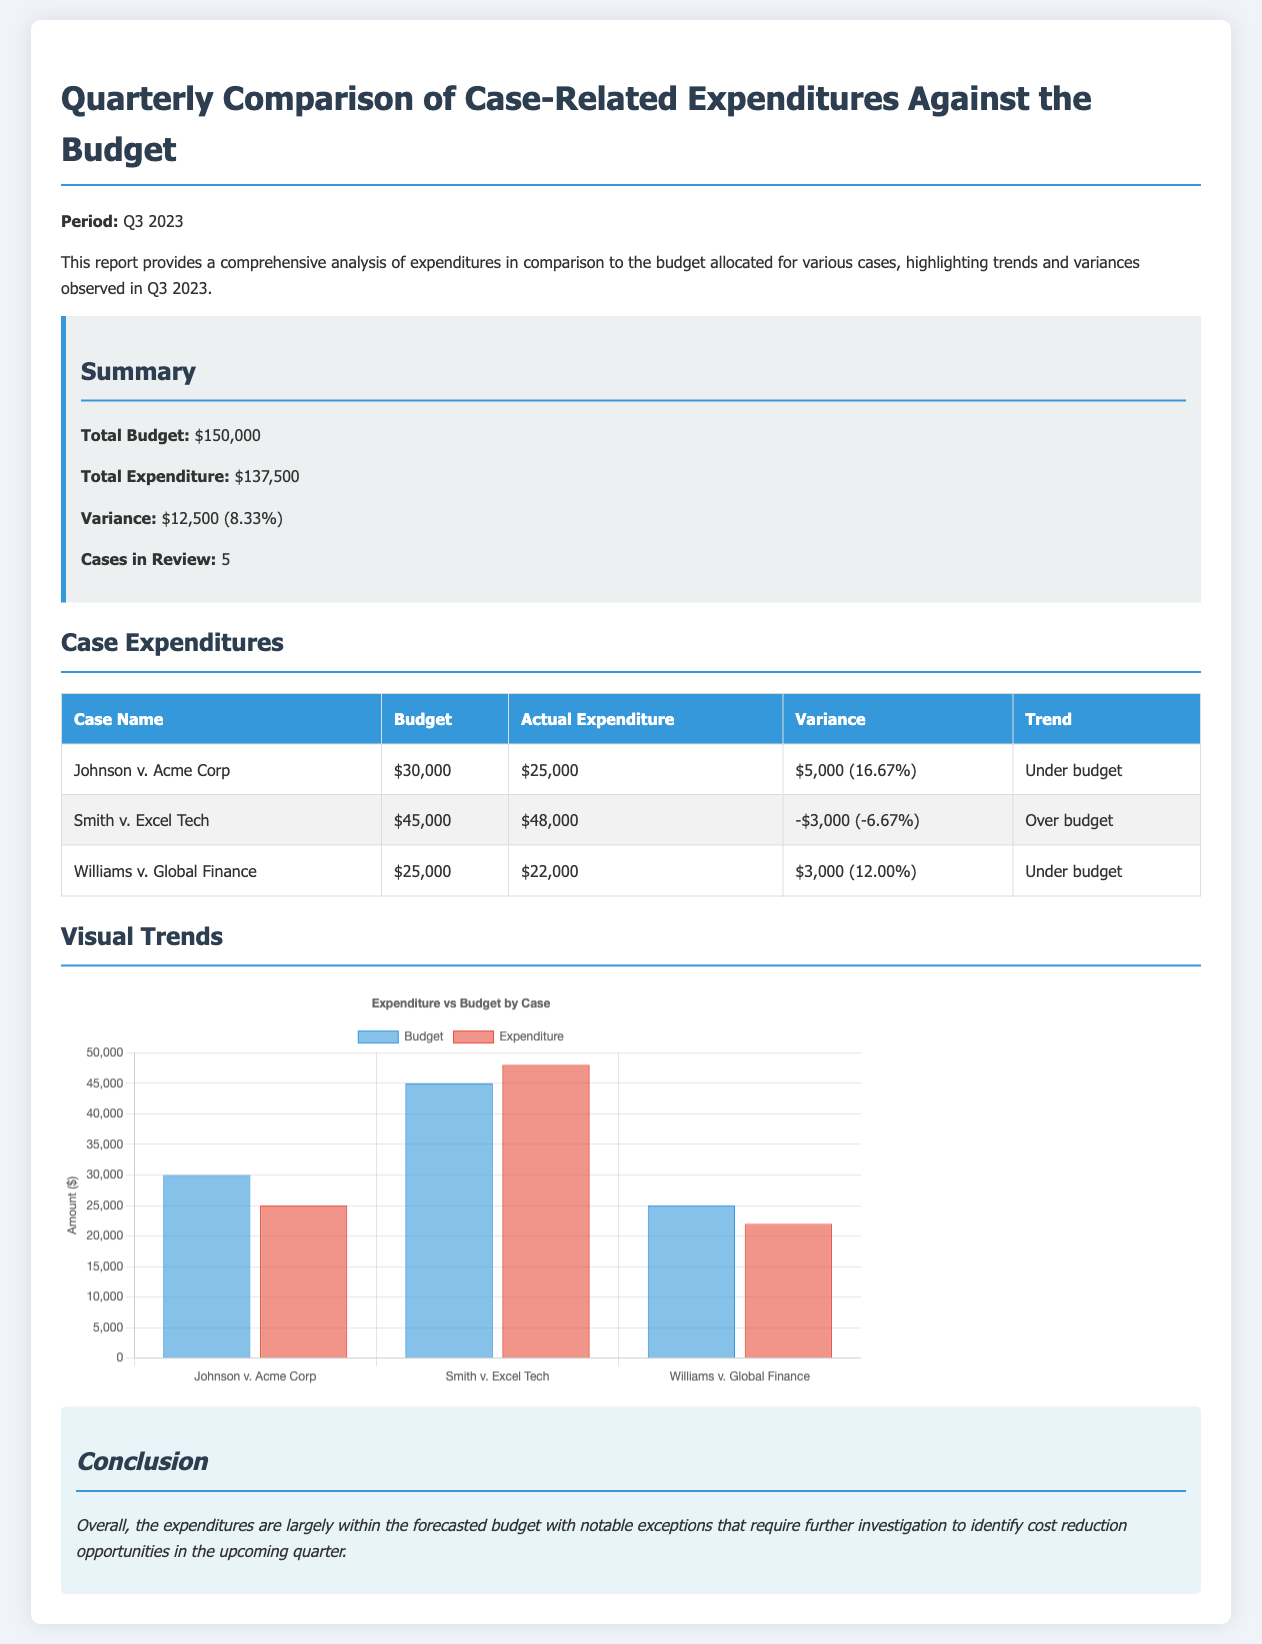What is the total budget? The total budget stated in the report is $150,000.
Answer: $150,000 What is the total expenditure? The total expenditure reported is $137,500.
Answer: $137,500 What is the variance percentage? The variance is indicated as 8.33%, which reflects the difference between the budget and actual expenditure.
Answer: 8.33% Which case is over budget? The case "Smith v. Excel Tech" has exceeded its budget.
Answer: Smith v. Excel Tech What is the budget for "Johnson v. Acme Corp"? The budget allocated for "Johnson v. Acme Corp" is $30,000.
Answer: $30,000 What is the actual expenditure for "Williams v. Global Finance"? The actual expenditure recorded for "Williams v. Global Finance" is $22,000.
Answer: $22,000 How many cases are in review? The report states there are five cases currently under review.
Answer: 5 What does the chart compare? The chart compares the budget and actual expenditure for each case.
Answer: Expenditure vs Budget Which case has the highest actual expenditure? "Smith v. Excel Tech" has the highest expenditure at $48,000.
Answer: Smith v. Excel Tech 